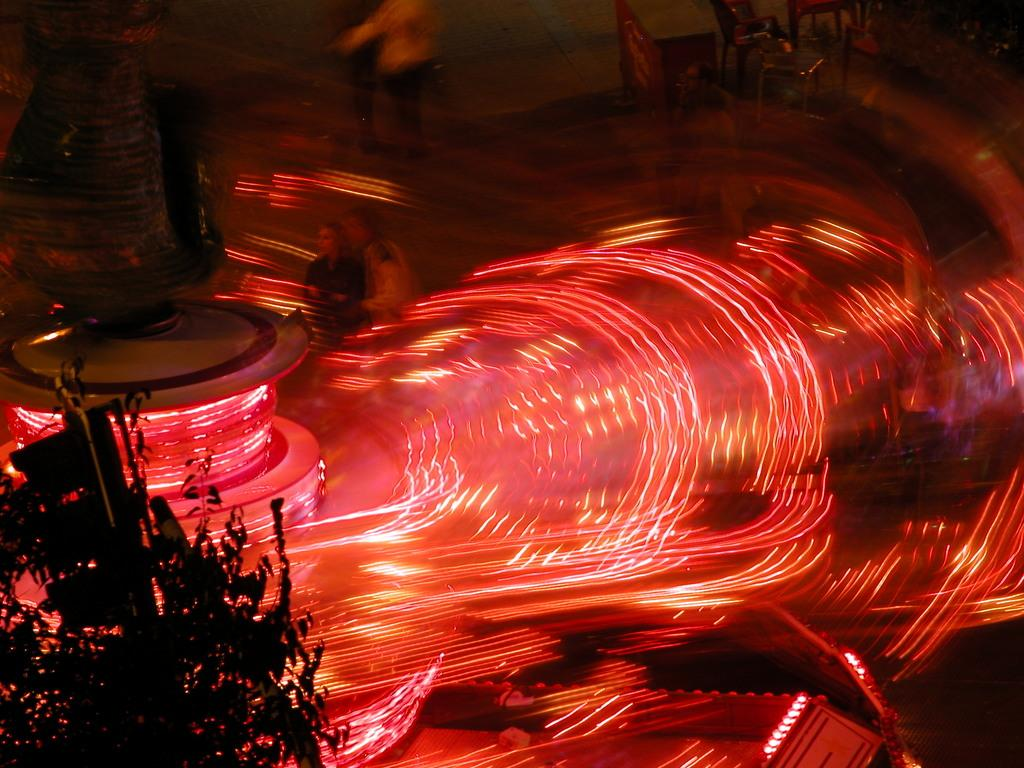What are the persons in the image doing? The persons in the image are walking. On what surface are the persons walking? The persons are walking on land. What can be seen on the left side of the image? There is a tree on the left side of the image. What is located in the middle of the image? There are lights in the middle of the image. What type of suit is the army wearing in the image? There is no army or suit present in the image. How many stitches are visible on the tree in the image? There are no stitches visible on the tree in the image; it is a natural object. 